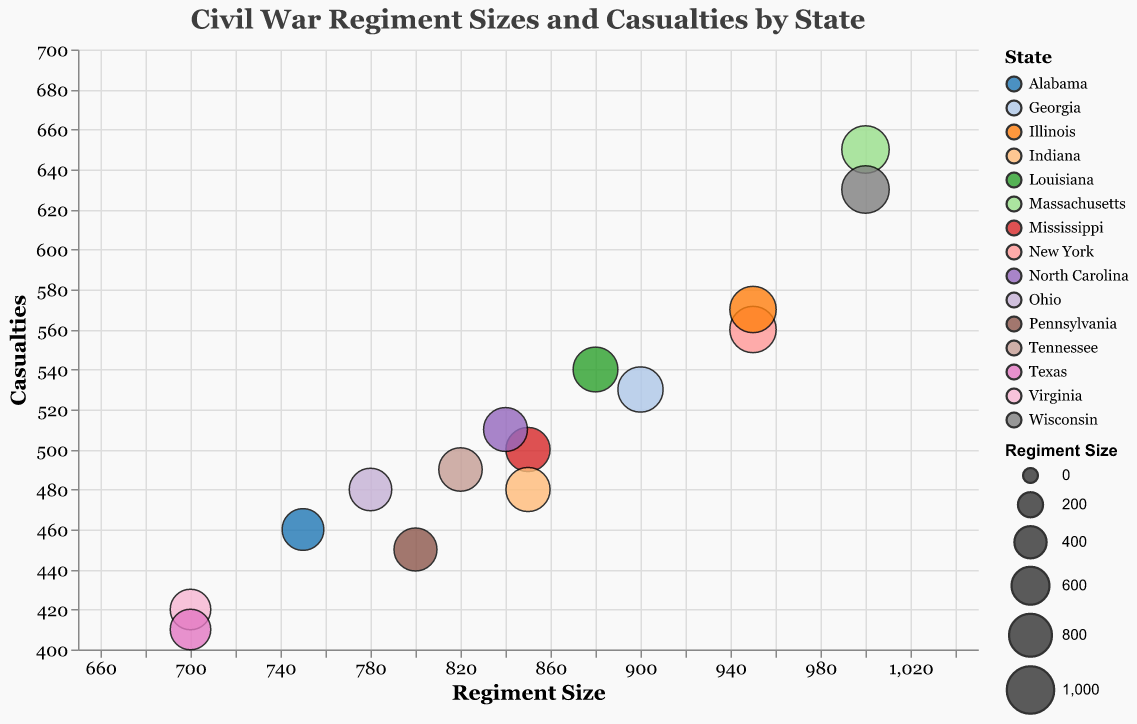What is the title of the chart? The title is displayed at the top of the chart and reads, "Civil War Regiment Sizes and Casualties by State".
Answer: Civil War Regiment Sizes and Casualties by State How many data points are represented in the chart? Each circle in the bubble chart represents one data point. There are a total of 15 circles, indicating 15 data points.
Answer: 15 Which regiment has the highest number of casualties? To find this, look for the highest point on the Y-axis, which corresponds to casualties. The "54th Massachusetts Volunteer Infantry" has the highest casualties at 650.
Answer: 54th Massachusetts Volunteer Infantry What's the difference in regiment size between the "54th Massachusetts Volunteer Infantry" and the "2nd Virginia Infantry"? "54th Massachusetts Volunteer Infantry" has a regiment size of 1000, and "2nd Virginia Infantry" has a regiment size of 700. The difference is 1000 - 700 = 300.
Answer: 300 Which state is represented by the smallest bubble? The size of the bubbles corresponds to the regiment size. The smallest bubble would be linked to the smallest regiment size, which is 700. Both Virginia ("2nd Virginia Infantry") and Texas ("11th Texas Infantry") have this size.
Answer: Virginia and Texas Compare the casualties between the "8th Illinois Infantry" and the "1st Pennsylvania Reserve Infantry". Which one had more casualties and by how much? "8th Illinois Infantry" has 570 casualties, and "1st Pennsylvania Reserve Infantry" has 450 casualties. 570 - 450 = 120, so "8th Illinois Infantry" had 120 more casualties.
Answer: 8th Illinois Infantry by 120 What is the average regiment size of the regiments from Ohio, Indiana, and Illinois? The regiment sizes are: Ohio (780), Indiana (850), Illinois (950). Calculate the average: (780 + 850 + 950) / 3 = 2580 / 3 = 860.
Answer: 860 What is the color of the bubble that represents the regiment with the highest casualties? The bubble representing the "54th Massachusetts Volunteer Infantry", which has the highest casualties, should be colored the same as the color assigned to Massachusetts by the chart's color coding.
Answer: The color assigned to Massachusetts (check the legend for exact color) Which regiment has the largest bubble, and what does the size of the bubble represent? The largest bubble represents the biggest regiment size, which is 1000 for both the "54th Massachusetts Volunteer Infantry" and the "2nd Wisconsin Infantry". The size of the bubble represents the regiment size.
Answer: 54th Massachusetts Volunteer Infantry and 2nd Wisconsin Infantry 